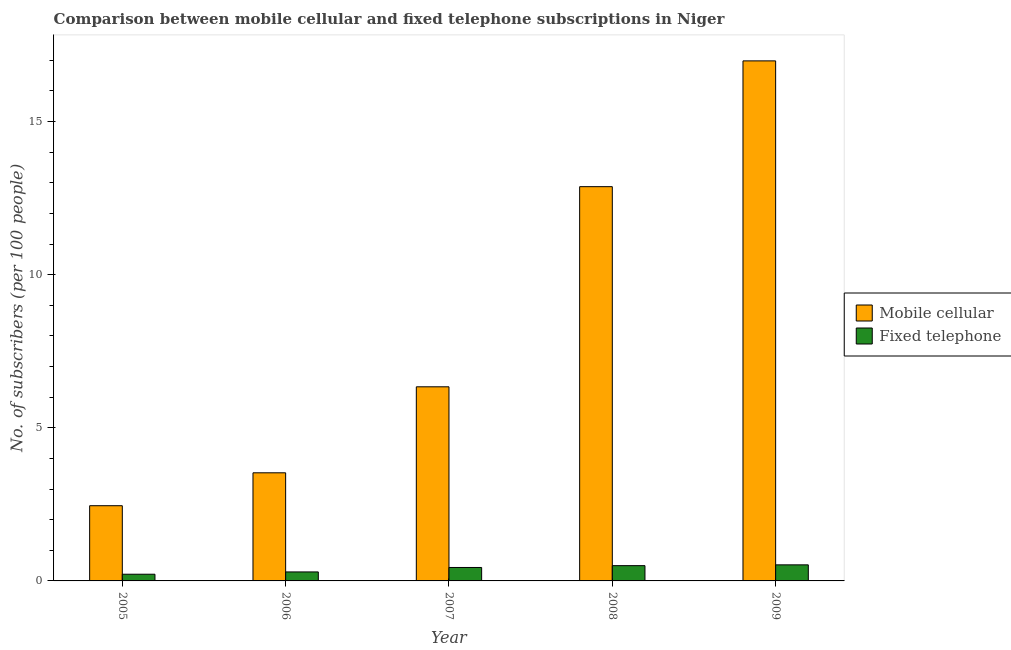How many different coloured bars are there?
Keep it short and to the point. 2. How many groups of bars are there?
Provide a short and direct response. 5. How many bars are there on the 2nd tick from the right?
Your response must be concise. 2. In how many cases, is the number of bars for a given year not equal to the number of legend labels?
Your answer should be very brief. 0. What is the number of fixed telephone subscribers in 2006?
Your answer should be compact. 0.29. Across all years, what is the maximum number of fixed telephone subscribers?
Give a very brief answer. 0.52. Across all years, what is the minimum number of mobile cellular subscribers?
Keep it short and to the point. 2.46. In which year was the number of fixed telephone subscribers minimum?
Offer a very short reply. 2005. What is the total number of fixed telephone subscribers in the graph?
Your answer should be very brief. 1.98. What is the difference between the number of fixed telephone subscribers in 2006 and that in 2007?
Provide a succinct answer. -0.15. What is the difference between the number of fixed telephone subscribers in 2005 and the number of mobile cellular subscribers in 2008?
Keep it short and to the point. -0.28. What is the average number of mobile cellular subscribers per year?
Your answer should be very brief. 8.44. In the year 2009, what is the difference between the number of fixed telephone subscribers and number of mobile cellular subscribers?
Make the answer very short. 0. In how many years, is the number of fixed telephone subscribers greater than 9?
Ensure brevity in your answer.  0. What is the ratio of the number of mobile cellular subscribers in 2007 to that in 2008?
Provide a short and direct response. 0.49. Is the number of mobile cellular subscribers in 2005 less than that in 2009?
Provide a succinct answer. Yes. What is the difference between the highest and the second highest number of mobile cellular subscribers?
Offer a very short reply. 4.11. What is the difference between the highest and the lowest number of mobile cellular subscribers?
Your answer should be compact. 14.53. In how many years, is the number of mobile cellular subscribers greater than the average number of mobile cellular subscribers taken over all years?
Give a very brief answer. 2. Is the sum of the number of mobile cellular subscribers in 2008 and 2009 greater than the maximum number of fixed telephone subscribers across all years?
Offer a terse response. Yes. What does the 2nd bar from the left in 2009 represents?
Your answer should be very brief. Fixed telephone. What does the 1st bar from the right in 2007 represents?
Offer a terse response. Fixed telephone. How many bars are there?
Your response must be concise. 10. Does the graph contain grids?
Your answer should be compact. No. How many legend labels are there?
Your answer should be compact. 2. What is the title of the graph?
Your answer should be very brief. Comparison between mobile cellular and fixed telephone subscriptions in Niger. Does "Male labourers" appear as one of the legend labels in the graph?
Provide a succinct answer. No. What is the label or title of the X-axis?
Provide a short and direct response. Year. What is the label or title of the Y-axis?
Your answer should be compact. No. of subscribers (per 100 people). What is the No. of subscribers (per 100 people) of Mobile cellular in 2005?
Offer a very short reply. 2.46. What is the No. of subscribers (per 100 people) of Fixed telephone in 2005?
Your answer should be very brief. 0.22. What is the No. of subscribers (per 100 people) of Mobile cellular in 2006?
Give a very brief answer. 3.53. What is the No. of subscribers (per 100 people) in Fixed telephone in 2006?
Provide a short and direct response. 0.29. What is the No. of subscribers (per 100 people) in Mobile cellular in 2007?
Your answer should be very brief. 6.34. What is the No. of subscribers (per 100 people) of Fixed telephone in 2007?
Ensure brevity in your answer.  0.44. What is the No. of subscribers (per 100 people) in Mobile cellular in 2008?
Make the answer very short. 12.88. What is the No. of subscribers (per 100 people) in Fixed telephone in 2008?
Your response must be concise. 0.5. What is the No. of subscribers (per 100 people) of Mobile cellular in 2009?
Ensure brevity in your answer.  16.98. What is the No. of subscribers (per 100 people) of Fixed telephone in 2009?
Give a very brief answer. 0.52. Across all years, what is the maximum No. of subscribers (per 100 people) of Mobile cellular?
Offer a very short reply. 16.98. Across all years, what is the maximum No. of subscribers (per 100 people) of Fixed telephone?
Provide a short and direct response. 0.52. Across all years, what is the minimum No. of subscribers (per 100 people) in Mobile cellular?
Make the answer very short. 2.46. Across all years, what is the minimum No. of subscribers (per 100 people) of Fixed telephone?
Keep it short and to the point. 0.22. What is the total No. of subscribers (per 100 people) of Mobile cellular in the graph?
Keep it short and to the point. 42.19. What is the total No. of subscribers (per 100 people) in Fixed telephone in the graph?
Make the answer very short. 1.98. What is the difference between the No. of subscribers (per 100 people) in Mobile cellular in 2005 and that in 2006?
Ensure brevity in your answer.  -1.07. What is the difference between the No. of subscribers (per 100 people) in Fixed telephone in 2005 and that in 2006?
Give a very brief answer. -0.07. What is the difference between the No. of subscribers (per 100 people) of Mobile cellular in 2005 and that in 2007?
Provide a short and direct response. -3.88. What is the difference between the No. of subscribers (per 100 people) of Fixed telephone in 2005 and that in 2007?
Make the answer very short. -0.22. What is the difference between the No. of subscribers (per 100 people) of Mobile cellular in 2005 and that in 2008?
Provide a short and direct response. -10.42. What is the difference between the No. of subscribers (per 100 people) of Fixed telephone in 2005 and that in 2008?
Ensure brevity in your answer.  -0.28. What is the difference between the No. of subscribers (per 100 people) of Mobile cellular in 2005 and that in 2009?
Provide a succinct answer. -14.53. What is the difference between the No. of subscribers (per 100 people) in Fixed telephone in 2005 and that in 2009?
Your answer should be very brief. -0.31. What is the difference between the No. of subscribers (per 100 people) of Mobile cellular in 2006 and that in 2007?
Your response must be concise. -2.81. What is the difference between the No. of subscribers (per 100 people) of Fixed telephone in 2006 and that in 2007?
Your response must be concise. -0.15. What is the difference between the No. of subscribers (per 100 people) in Mobile cellular in 2006 and that in 2008?
Your response must be concise. -9.35. What is the difference between the No. of subscribers (per 100 people) of Fixed telephone in 2006 and that in 2008?
Your answer should be very brief. -0.21. What is the difference between the No. of subscribers (per 100 people) of Mobile cellular in 2006 and that in 2009?
Your answer should be compact. -13.45. What is the difference between the No. of subscribers (per 100 people) in Fixed telephone in 2006 and that in 2009?
Your answer should be very brief. -0.23. What is the difference between the No. of subscribers (per 100 people) of Mobile cellular in 2007 and that in 2008?
Keep it short and to the point. -6.54. What is the difference between the No. of subscribers (per 100 people) in Fixed telephone in 2007 and that in 2008?
Give a very brief answer. -0.06. What is the difference between the No. of subscribers (per 100 people) in Mobile cellular in 2007 and that in 2009?
Your response must be concise. -10.64. What is the difference between the No. of subscribers (per 100 people) of Fixed telephone in 2007 and that in 2009?
Offer a very short reply. -0.09. What is the difference between the No. of subscribers (per 100 people) in Mobile cellular in 2008 and that in 2009?
Keep it short and to the point. -4.11. What is the difference between the No. of subscribers (per 100 people) in Fixed telephone in 2008 and that in 2009?
Your answer should be compact. -0.03. What is the difference between the No. of subscribers (per 100 people) in Mobile cellular in 2005 and the No. of subscribers (per 100 people) in Fixed telephone in 2006?
Give a very brief answer. 2.16. What is the difference between the No. of subscribers (per 100 people) in Mobile cellular in 2005 and the No. of subscribers (per 100 people) in Fixed telephone in 2007?
Give a very brief answer. 2.02. What is the difference between the No. of subscribers (per 100 people) of Mobile cellular in 2005 and the No. of subscribers (per 100 people) of Fixed telephone in 2008?
Make the answer very short. 1.96. What is the difference between the No. of subscribers (per 100 people) of Mobile cellular in 2005 and the No. of subscribers (per 100 people) of Fixed telephone in 2009?
Your answer should be compact. 1.93. What is the difference between the No. of subscribers (per 100 people) of Mobile cellular in 2006 and the No. of subscribers (per 100 people) of Fixed telephone in 2007?
Make the answer very short. 3.09. What is the difference between the No. of subscribers (per 100 people) in Mobile cellular in 2006 and the No. of subscribers (per 100 people) in Fixed telephone in 2008?
Your response must be concise. 3.03. What is the difference between the No. of subscribers (per 100 people) of Mobile cellular in 2006 and the No. of subscribers (per 100 people) of Fixed telephone in 2009?
Your answer should be very brief. 3.01. What is the difference between the No. of subscribers (per 100 people) in Mobile cellular in 2007 and the No. of subscribers (per 100 people) in Fixed telephone in 2008?
Provide a succinct answer. 5.84. What is the difference between the No. of subscribers (per 100 people) of Mobile cellular in 2007 and the No. of subscribers (per 100 people) of Fixed telephone in 2009?
Your answer should be very brief. 5.81. What is the difference between the No. of subscribers (per 100 people) of Mobile cellular in 2008 and the No. of subscribers (per 100 people) of Fixed telephone in 2009?
Offer a very short reply. 12.35. What is the average No. of subscribers (per 100 people) of Mobile cellular per year?
Ensure brevity in your answer.  8.44. What is the average No. of subscribers (per 100 people) of Fixed telephone per year?
Give a very brief answer. 0.4. In the year 2005, what is the difference between the No. of subscribers (per 100 people) of Mobile cellular and No. of subscribers (per 100 people) of Fixed telephone?
Offer a very short reply. 2.24. In the year 2006, what is the difference between the No. of subscribers (per 100 people) of Mobile cellular and No. of subscribers (per 100 people) of Fixed telephone?
Provide a succinct answer. 3.24. In the year 2008, what is the difference between the No. of subscribers (per 100 people) in Mobile cellular and No. of subscribers (per 100 people) in Fixed telephone?
Make the answer very short. 12.38. In the year 2009, what is the difference between the No. of subscribers (per 100 people) of Mobile cellular and No. of subscribers (per 100 people) of Fixed telephone?
Your response must be concise. 16.46. What is the ratio of the No. of subscribers (per 100 people) of Mobile cellular in 2005 to that in 2006?
Keep it short and to the point. 0.7. What is the ratio of the No. of subscribers (per 100 people) in Fixed telephone in 2005 to that in 2006?
Your answer should be compact. 0.74. What is the ratio of the No. of subscribers (per 100 people) of Mobile cellular in 2005 to that in 2007?
Ensure brevity in your answer.  0.39. What is the ratio of the No. of subscribers (per 100 people) in Fixed telephone in 2005 to that in 2007?
Provide a short and direct response. 0.5. What is the ratio of the No. of subscribers (per 100 people) of Mobile cellular in 2005 to that in 2008?
Offer a very short reply. 0.19. What is the ratio of the No. of subscribers (per 100 people) in Fixed telephone in 2005 to that in 2008?
Ensure brevity in your answer.  0.44. What is the ratio of the No. of subscribers (per 100 people) of Mobile cellular in 2005 to that in 2009?
Ensure brevity in your answer.  0.14. What is the ratio of the No. of subscribers (per 100 people) in Fixed telephone in 2005 to that in 2009?
Offer a very short reply. 0.42. What is the ratio of the No. of subscribers (per 100 people) in Mobile cellular in 2006 to that in 2007?
Keep it short and to the point. 0.56. What is the ratio of the No. of subscribers (per 100 people) of Fixed telephone in 2006 to that in 2007?
Your answer should be compact. 0.67. What is the ratio of the No. of subscribers (per 100 people) in Mobile cellular in 2006 to that in 2008?
Ensure brevity in your answer.  0.27. What is the ratio of the No. of subscribers (per 100 people) in Fixed telephone in 2006 to that in 2008?
Give a very brief answer. 0.59. What is the ratio of the No. of subscribers (per 100 people) of Mobile cellular in 2006 to that in 2009?
Ensure brevity in your answer.  0.21. What is the ratio of the No. of subscribers (per 100 people) in Fixed telephone in 2006 to that in 2009?
Provide a succinct answer. 0.56. What is the ratio of the No. of subscribers (per 100 people) in Mobile cellular in 2007 to that in 2008?
Give a very brief answer. 0.49. What is the ratio of the No. of subscribers (per 100 people) of Fixed telephone in 2007 to that in 2008?
Your answer should be very brief. 0.88. What is the ratio of the No. of subscribers (per 100 people) of Mobile cellular in 2007 to that in 2009?
Your response must be concise. 0.37. What is the ratio of the No. of subscribers (per 100 people) of Fixed telephone in 2007 to that in 2009?
Provide a succinct answer. 0.84. What is the ratio of the No. of subscribers (per 100 people) in Mobile cellular in 2008 to that in 2009?
Offer a very short reply. 0.76. What is the ratio of the No. of subscribers (per 100 people) of Fixed telephone in 2008 to that in 2009?
Offer a very short reply. 0.95. What is the difference between the highest and the second highest No. of subscribers (per 100 people) of Mobile cellular?
Offer a very short reply. 4.11. What is the difference between the highest and the second highest No. of subscribers (per 100 people) of Fixed telephone?
Ensure brevity in your answer.  0.03. What is the difference between the highest and the lowest No. of subscribers (per 100 people) in Mobile cellular?
Give a very brief answer. 14.53. What is the difference between the highest and the lowest No. of subscribers (per 100 people) of Fixed telephone?
Make the answer very short. 0.31. 